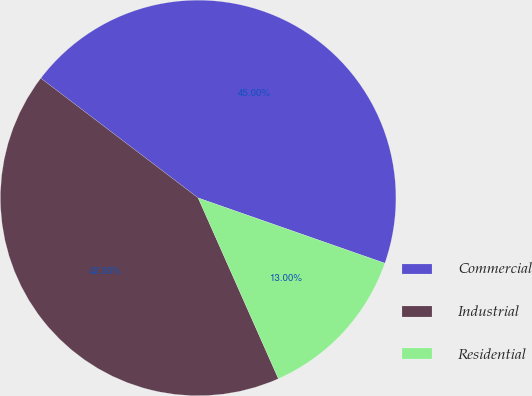<chart> <loc_0><loc_0><loc_500><loc_500><pie_chart><fcel>Commercial<fcel>Industrial<fcel>Residential<nl><fcel>45.0%<fcel>42.0%<fcel>13.0%<nl></chart> 